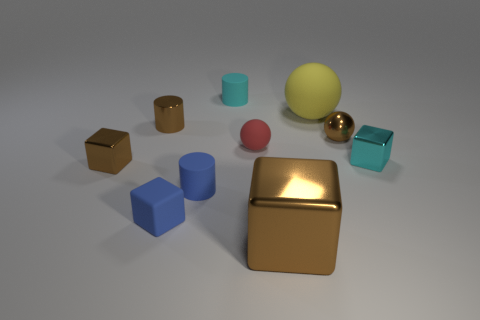Subtract 1 blocks. How many blocks are left? 3 Subtract all cubes. How many objects are left? 6 Add 9 blue blocks. How many blue blocks exist? 10 Subtract 0 gray cubes. How many objects are left? 10 Subtract all green rubber spheres. Subtract all big blocks. How many objects are left? 9 Add 1 blue things. How many blue things are left? 3 